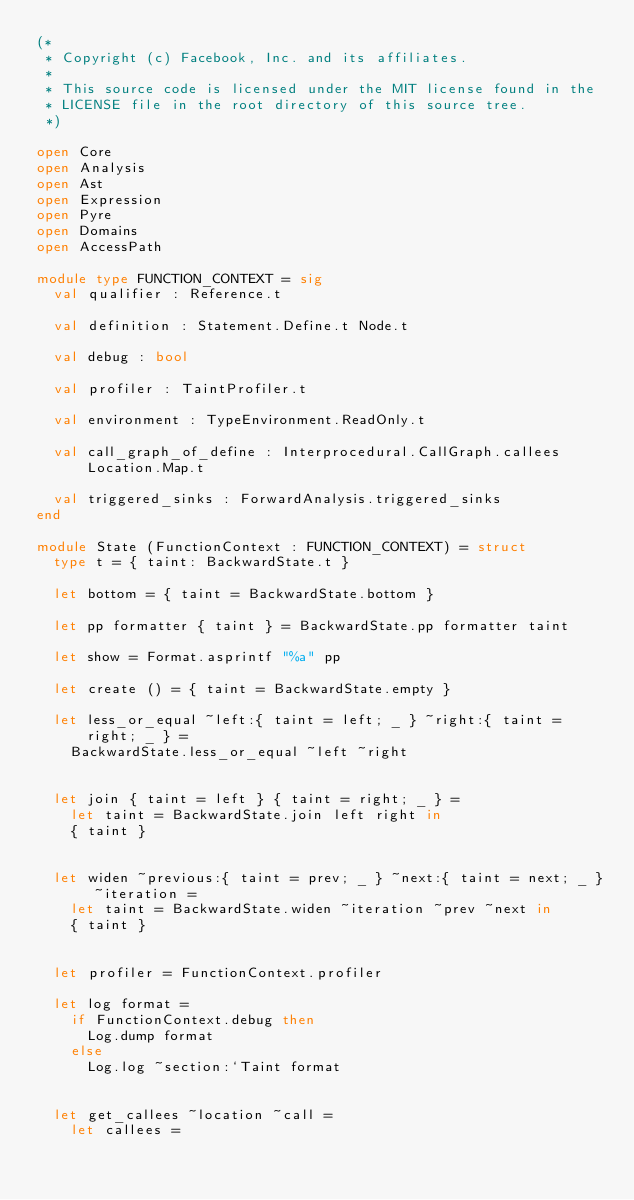Convert code to text. <code><loc_0><loc_0><loc_500><loc_500><_OCaml_>(*
 * Copyright (c) Facebook, Inc. and its affiliates.
 *
 * This source code is licensed under the MIT license found in the
 * LICENSE file in the root directory of this source tree.
 *)

open Core
open Analysis
open Ast
open Expression
open Pyre
open Domains
open AccessPath

module type FUNCTION_CONTEXT = sig
  val qualifier : Reference.t

  val definition : Statement.Define.t Node.t

  val debug : bool

  val profiler : TaintProfiler.t

  val environment : TypeEnvironment.ReadOnly.t

  val call_graph_of_define : Interprocedural.CallGraph.callees Location.Map.t

  val triggered_sinks : ForwardAnalysis.triggered_sinks
end

module State (FunctionContext : FUNCTION_CONTEXT) = struct
  type t = { taint: BackwardState.t }

  let bottom = { taint = BackwardState.bottom }

  let pp formatter { taint } = BackwardState.pp formatter taint

  let show = Format.asprintf "%a" pp

  let create () = { taint = BackwardState.empty }

  let less_or_equal ~left:{ taint = left; _ } ~right:{ taint = right; _ } =
    BackwardState.less_or_equal ~left ~right


  let join { taint = left } { taint = right; _ } =
    let taint = BackwardState.join left right in
    { taint }


  let widen ~previous:{ taint = prev; _ } ~next:{ taint = next; _ } ~iteration =
    let taint = BackwardState.widen ~iteration ~prev ~next in
    { taint }


  let profiler = FunctionContext.profiler

  let log format =
    if FunctionContext.debug then
      Log.dump format
    else
      Log.log ~section:`Taint format


  let get_callees ~location ~call =
    let callees =</code> 